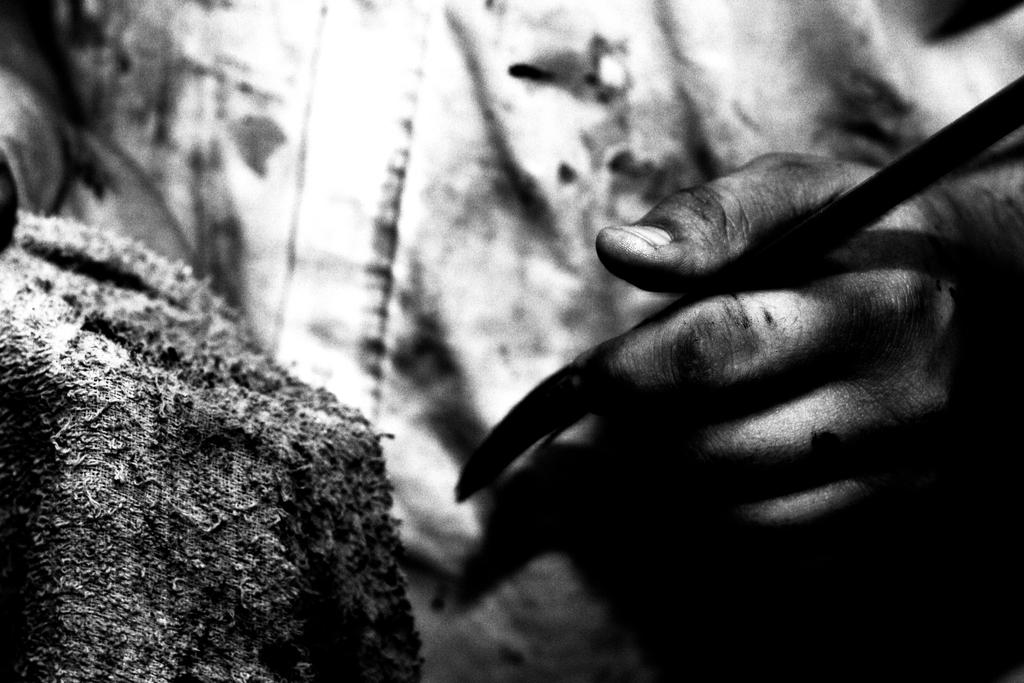What can be seen in the image involving a person's hand? There is a person's hand holding something in the image. What type of paste is being applied to the stamp in the image? There is no paste or stamp present in the image; it only shows a person's hand holding something. 